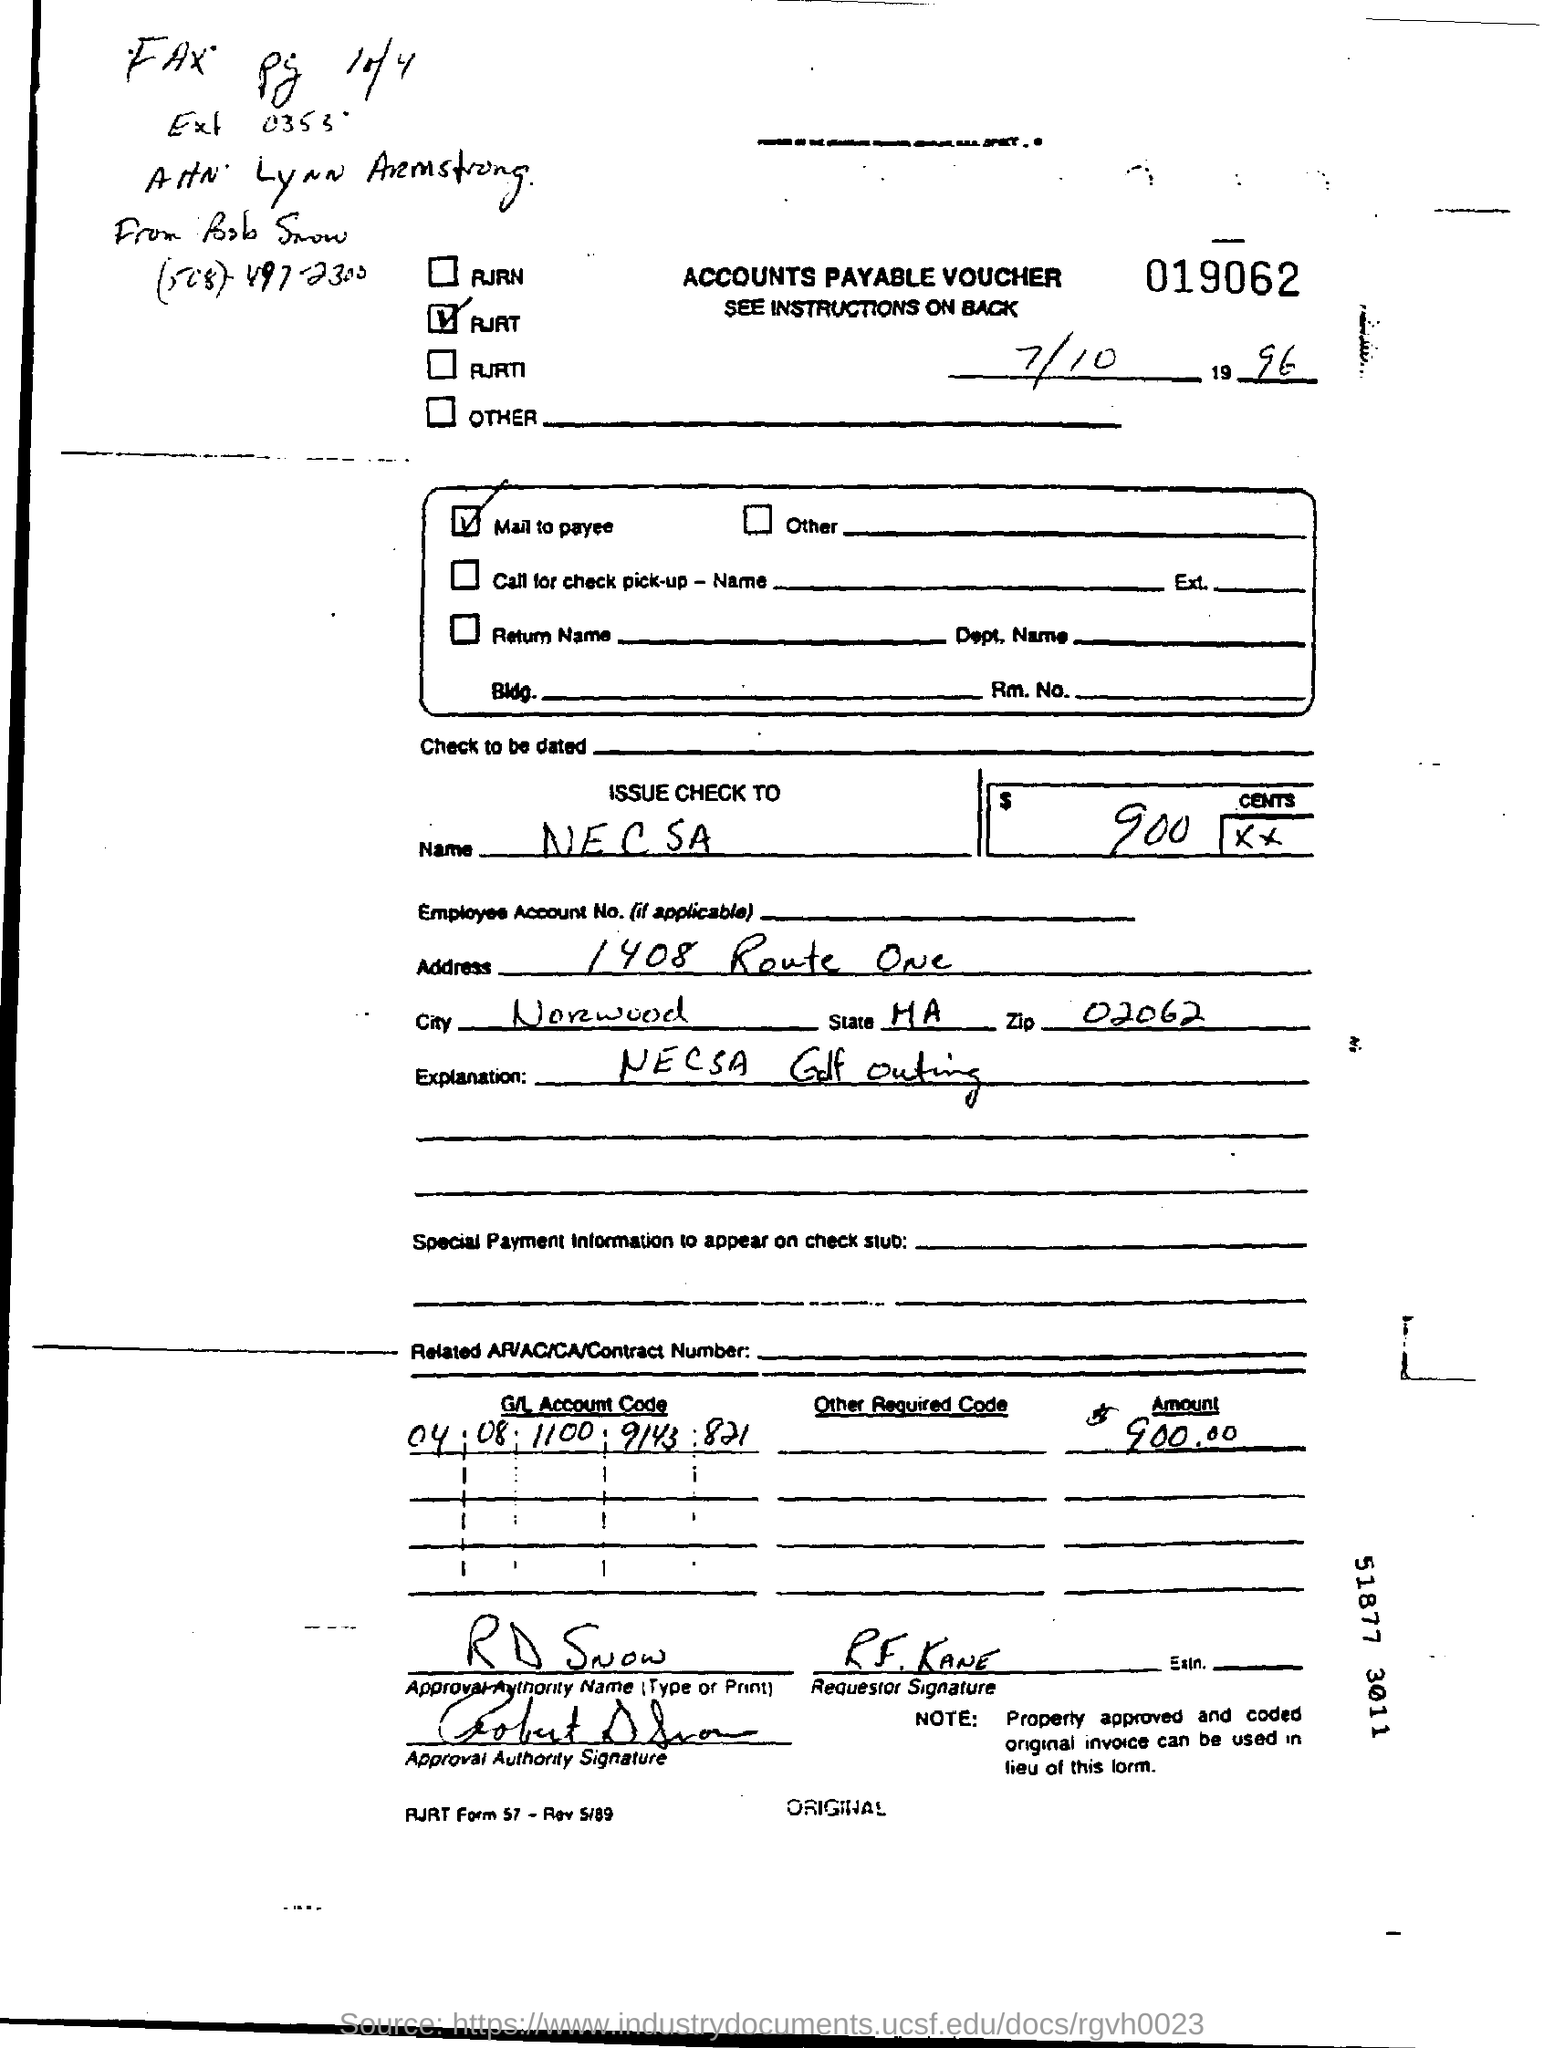In which name, the check is issued to?
Your answer should be compact. N E C S A. Who is the approval authority as per the voucher?
Ensure brevity in your answer.  R D Snow. What is the zip code mentioned in the address?
Provide a succinct answer. 02062. What is the amount given in the voucher?
Keep it short and to the point. 900.00. What is the G/L account code mentioned in the voucher?
Provide a succinct answer. 04 08 1100 9143 821. 